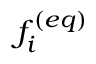<formula> <loc_0><loc_0><loc_500><loc_500>f _ { i } ^ { ( e q ) }</formula> 